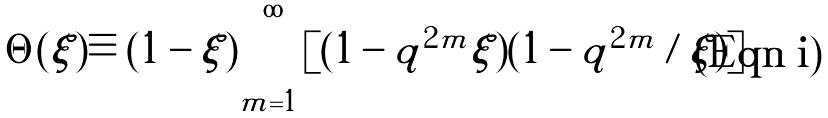<formula> <loc_0><loc_0><loc_500><loc_500>\Theta ( \xi ) \equiv ( 1 - \xi ) \prod _ { m = 1 } ^ { \infty } [ ( 1 - q ^ { 2 m } \xi ) ( 1 - q ^ { 2 m } / \xi ) ]</formula> 